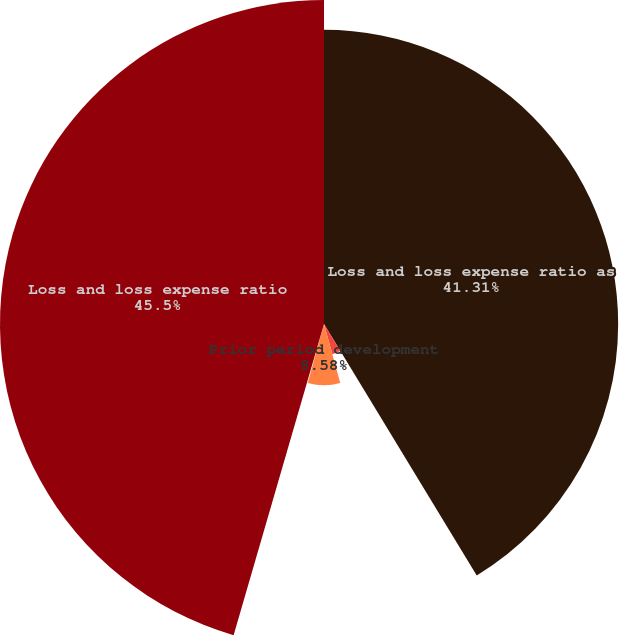Convert chart. <chart><loc_0><loc_0><loc_500><loc_500><pie_chart><fcel>Loss and loss expense ratio as<fcel>Catastrophe losses and related<fcel>Prior period development<fcel>Large assumed loss portfolio<fcel>Loss and loss expense ratio<nl><fcel>41.31%<fcel>4.4%<fcel>8.58%<fcel>0.21%<fcel>45.5%<nl></chart> 